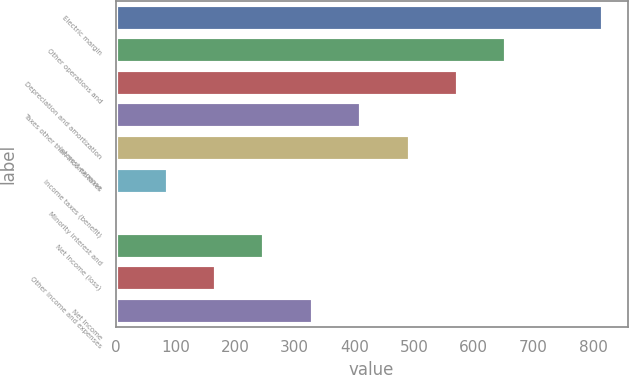Convert chart. <chart><loc_0><loc_0><loc_500><loc_500><bar_chart><fcel>Electric margin<fcel>Other operations and<fcel>Depreciation and amortization<fcel>Taxes other than income taxes<fcel>Interest expense<fcel>Income taxes (benefit)<fcel>Minority interest and<fcel>Net Income (loss)<fcel>Other income and expenses<fcel>Net Income<nl><fcel>817<fcel>654.8<fcel>573.7<fcel>411.5<fcel>492.6<fcel>87.1<fcel>6<fcel>249.3<fcel>168.2<fcel>330.4<nl></chart> 